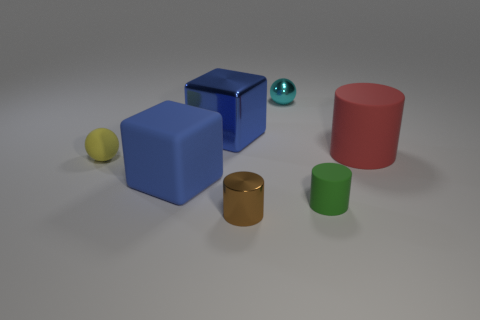There is a big rubber thing that is to the left of the green cylinder; is it the same color as the big block that is behind the big blue rubber thing?
Your answer should be very brief. Yes. There is a matte cube that is the same color as the big metallic object; what size is it?
Ensure brevity in your answer.  Large. Is there a tiny cylinder made of the same material as the brown thing?
Provide a short and direct response. No. Is the small cyan sphere made of the same material as the brown cylinder?
Make the answer very short. Yes. How many blue rubber cubes are to the left of the tiny metal thing in front of the metallic cube?
Make the answer very short. 1. How many cyan things are either metal objects or tiny things?
Provide a succinct answer. 1. What shape is the shiny object behind the blue object on the right side of the big blue thing that is on the left side of the large shiny thing?
Your answer should be very brief. Sphere. There is a rubber ball that is the same size as the green cylinder; what color is it?
Your answer should be compact. Yellow. What number of other rubber things have the same shape as the cyan object?
Make the answer very short. 1. Do the red rubber object and the blue thing left of the large shiny cube have the same size?
Provide a succinct answer. Yes. 